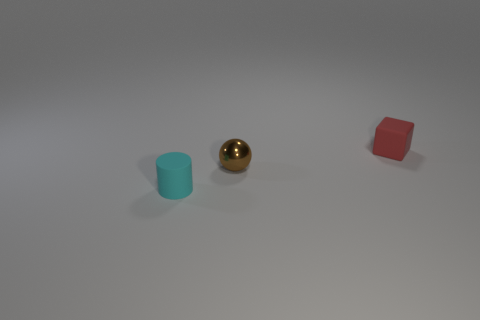There is a matte thing that is right of the cyan cylinder; is its size the same as the ball?
Keep it short and to the point. Yes. What number of metallic things are big brown cylinders or small blocks?
Provide a short and direct response. 0. There is a thing that is on the right side of the cyan cylinder and to the left of the tiny red matte cube; what is its material?
Make the answer very short. Metal. Are the brown object and the cylinder made of the same material?
Your answer should be very brief. No. There is a thing that is both to the left of the red thing and behind the cyan matte cylinder; what is its size?
Provide a short and direct response. Small. There is a tiny brown metallic thing; what shape is it?
Your answer should be compact. Sphere. How many objects are either cyan matte objects or small objects right of the brown shiny thing?
Make the answer very short. 2. There is a rubber thing that is behind the brown metal thing; is it the same color as the metal ball?
Offer a terse response. No. What is the color of the tiny object that is on the right side of the tiny cyan rubber object and in front of the small red block?
Your answer should be very brief. Brown. There is a tiny thing that is to the right of the ball; what is its material?
Make the answer very short. Rubber. 